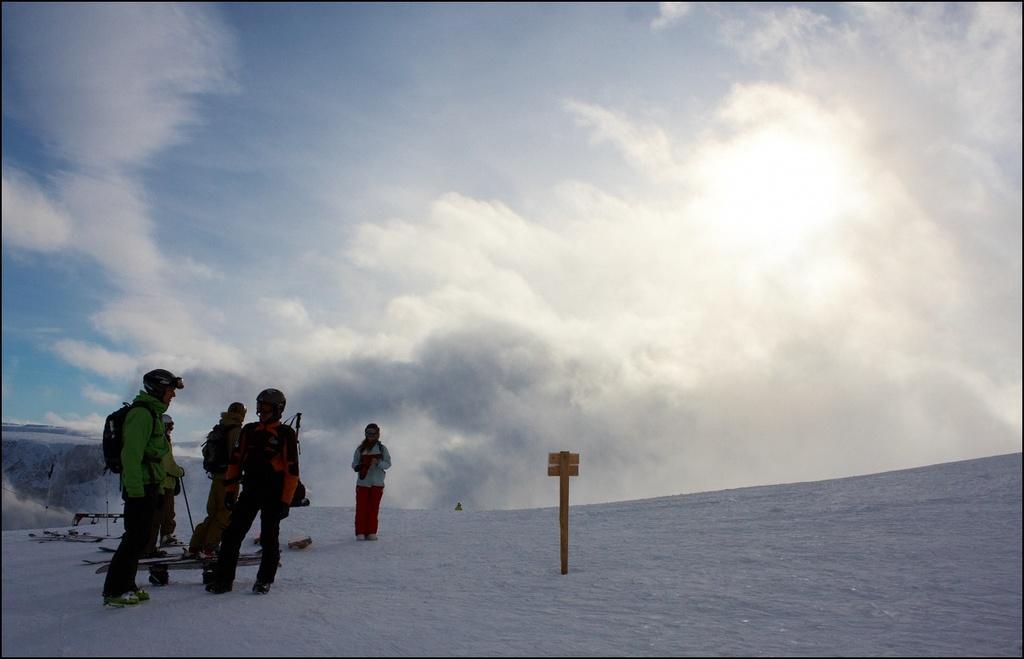Please provide a concise description of this image. In the picture we can see the snow surface on it, we can see a pole with a board which is yellow in color and beside it, we can see some people are standing they are wearing jackets, helmets and holding sticks and in the background we can see the sky with clouds. 